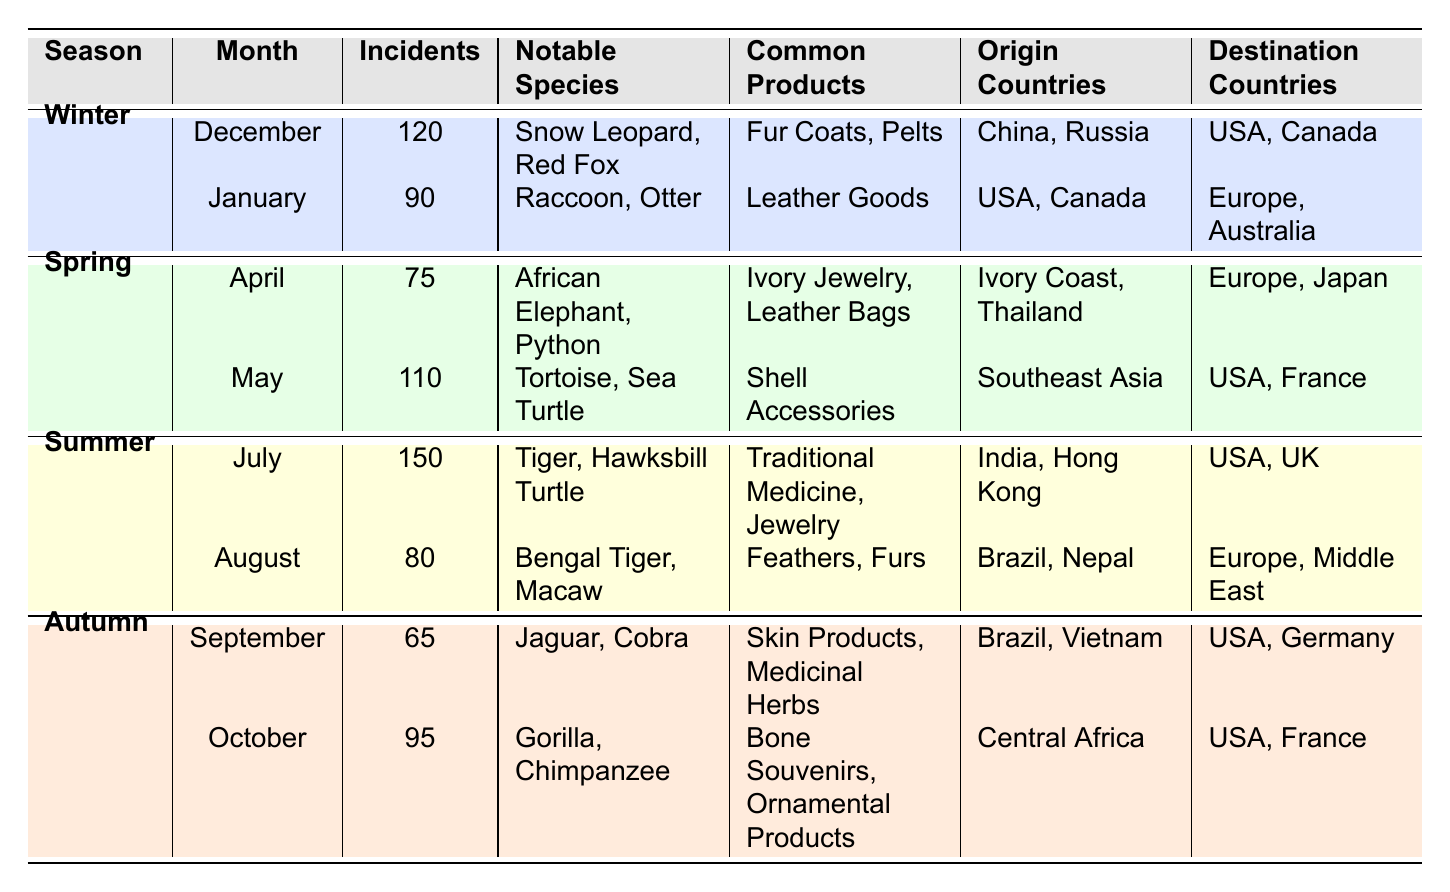What season had the highest number of smuggling incidents? By examining the "Incident Count" column for each season, I see that Summer had the highest count of 150 incidents in July.
Answer: Summer How many incidents were reported in Autumn? To find the total incidents in Autumn, I sum the counts from September (65) and October (95): 65 + 95 = 160.
Answer: 160 Was "Leather Goods" listed as a common product in Winter? "Leather Goods" appears in the January row under Winter, indicating that it is indeed a common product for that season.
Answer: Yes Which notable species were involved in the May incidents? In May, the notable species listed are Tortoise and Sea Turtle.
Answer: Tortoise, Sea Turtle In which month was the number of incidents related to the Snow Leopard recorded? The Snow Leopard is noted in the December row, which corresponds to Winter.
Answer: December What is the average number of incidents reported across all seasons? To find the average, I first add all incident counts: 120 + 90 + 75 + 110 + 150 + 80 + 65 + 95 = 780. There are 8 data points, so the average is 780 / 8 = 97.5.
Answer: 97.5 Is it true that all incidents in Spring involved species from Africa? Looking at the Spring rows, the notable species in April are African Elephant and Python, while in May, Tortoise is noted, which primarily comes from Southeast Asia. Therefore, not all species are from Africa.
Answer: No What are the common products among incidents in Spring and Summer combined? The common products in Spring (Ivory Jewelry, Leather Bags, Shell Accessories) and Summer (Traditional Medicine, Jewelry, Feathers, Furs) include a variety of items, with unique products in each season. There are no overlaps, so the products are all unique.
Answer: No common products 